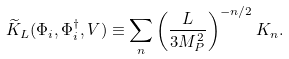<formula> <loc_0><loc_0><loc_500><loc_500>\widetilde { K } _ { L } ( \Phi _ { i } , \Phi ^ { \dagger } _ { i } , V ) \equiv \sum _ { n } \left ( \frac { L } { 3 M _ { P } ^ { 2 } } \right ) ^ { - n / 2 } K _ { n } .</formula> 